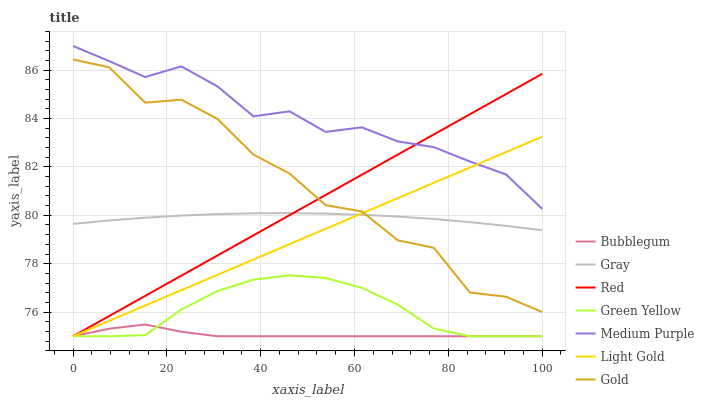Does Bubblegum have the minimum area under the curve?
Answer yes or no. Yes. Does Medium Purple have the maximum area under the curve?
Answer yes or no. Yes. Does Gold have the minimum area under the curve?
Answer yes or no. No. Does Gold have the maximum area under the curve?
Answer yes or no. No. Is Light Gold the smoothest?
Answer yes or no. Yes. Is Gold the roughest?
Answer yes or no. Yes. Is Bubblegum the smoothest?
Answer yes or no. No. Is Bubblegum the roughest?
Answer yes or no. No. Does Gold have the lowest value?
Answer yes or no. No. Does Medium Purple have the highest value?
Answer yes or no. Yes. Does Gold have the highest value?
Answer yes or no. No. Is Green Yellow less than Gold?
Answer yes or no. Yes. Is Medium Purple greater than Gray?
Answer yes or no. Yes. Does Light Gold intersect Gold?
Answer yes or no. Yes. Is Light Gold less than Gold?
Answer yes or no. No. Is Light Gold greater than Gold?
Answer yes or no. No. Does Green Yellow intersect Gold?
Answer yes or no. No. 